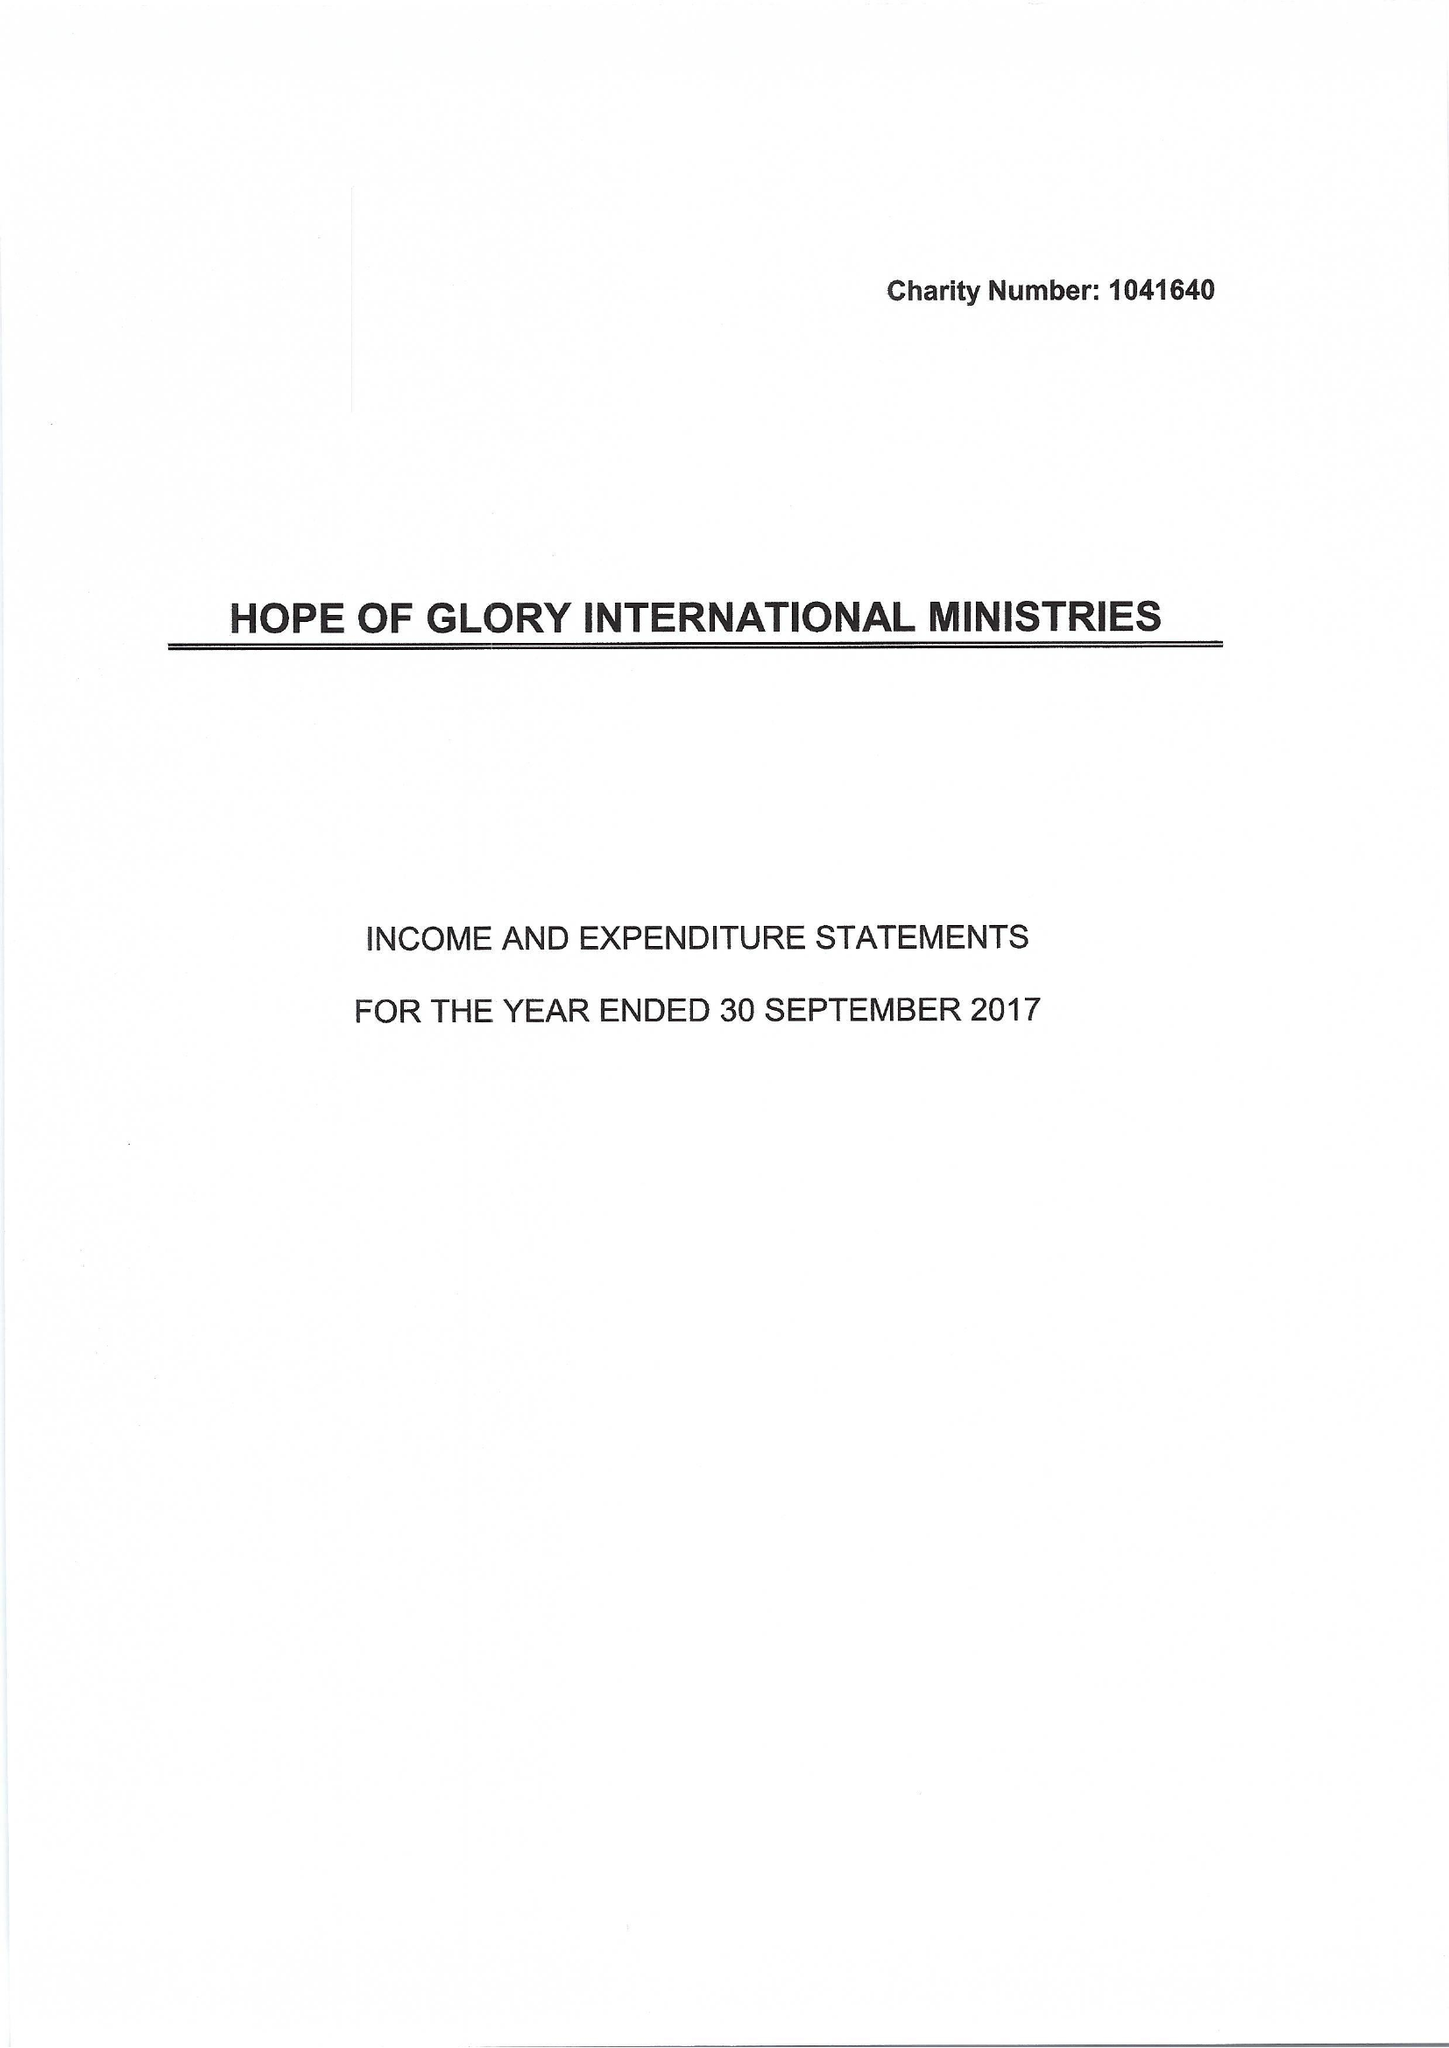What is the value for the address__post_town?
Answer the question using a single word or phrase. BEXLEYHEATH 